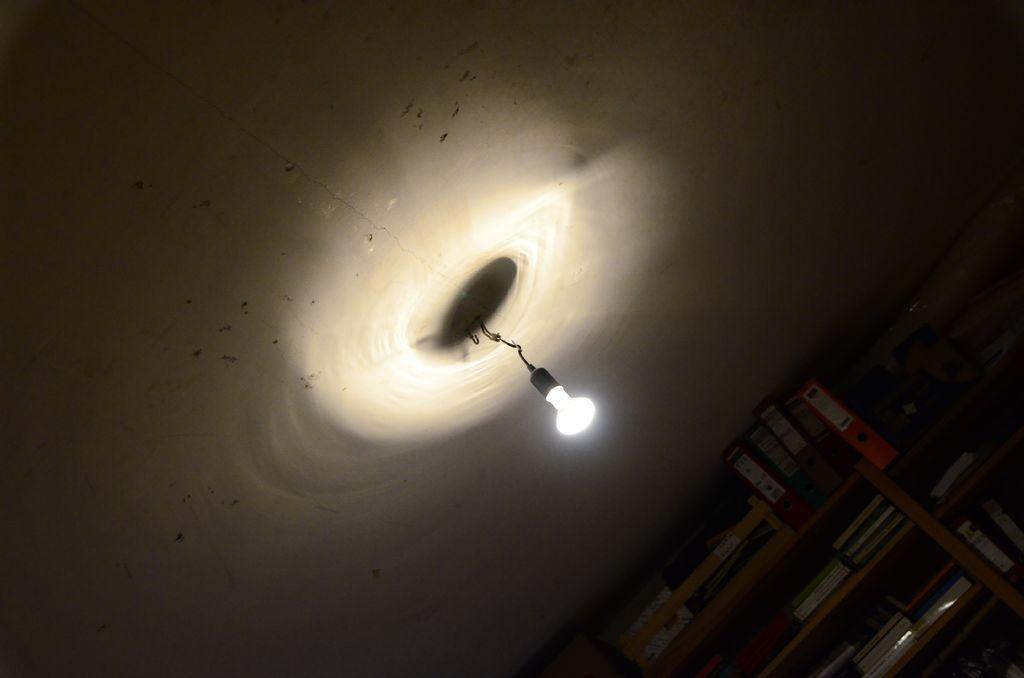How would you summarize this image in a sentence or two? In this image we can see books and files placed in the rack. In the center we can see a light. In the background there is a roof. 